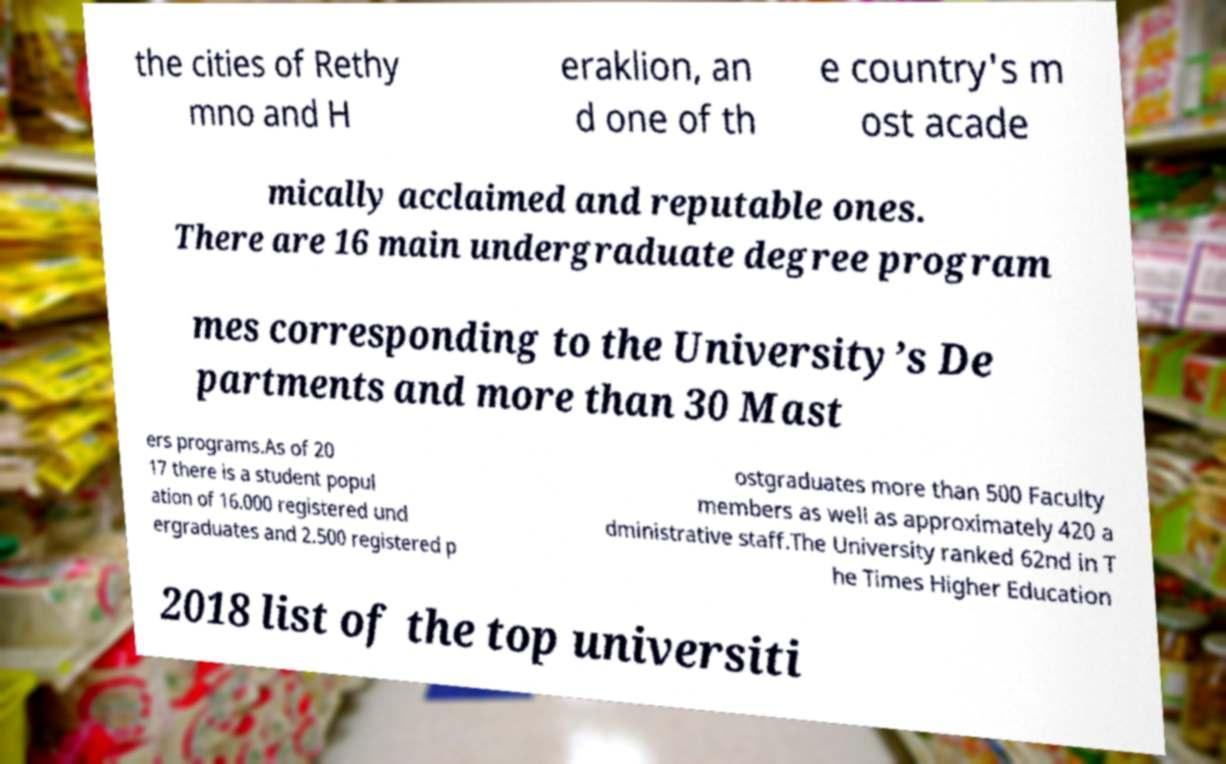I need the written content from this picture converted into text. Can you do that? the cities of Rethy mno and H eraklion, an d one of th e country's m ost acade mically acclaimed and reputable ones. There are 16 main undergraduate degree program mes corresponding to the University’s De partments and more than 30 Mast ers programs.As of 20 17 there is a student popul ation of 16.000 registered und ergraduates and 2.500 registered p ostgraduates more than 500 Faculty members as well as approximately 420 a dministrative staff.The University ranked 62nd in T he Times Higher Education 2018 list of the top universiti 